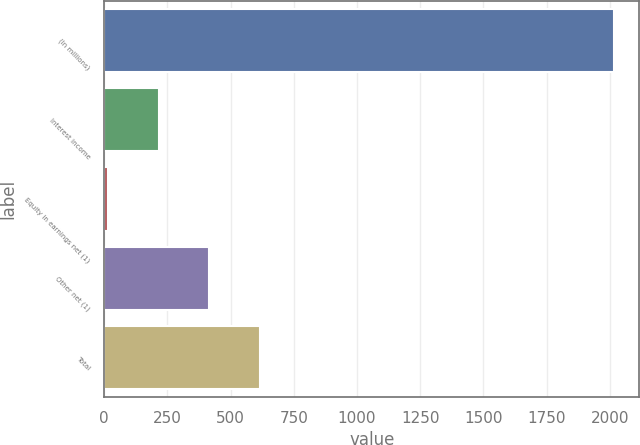<chart> <loc_0><loc_0><loc_500><loc_500><bar_chart><fcel>(In millions)<fcel>Interest income<fcel>Equity in earnings net (1)<fcel>Other net (1)<fcel>Total<nl><fcel>2016<fcel>215.1<fcel>15<fcel>415.2<fcel>615.3<nl></chart> 